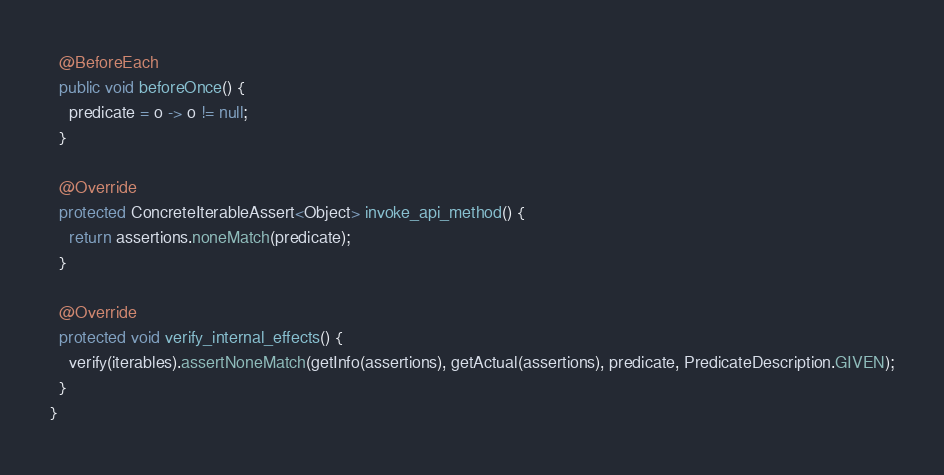Convert code to text. <code><loc_0><loc_0><loc_500><loc_500><_Java_>
  @BeforeEach
  public void beforeOnce() {
    predicate = o -> o != null;
  }

  @Override
  protected ConcreteIterableAssert<Object> invoke_api_method() {
    return assertions.noneMatch(predicate);
  }

  @Override
  protected void verify_internal_effects() {
    verify(iterables).assertNoneMatch(getInfo(assertions), getActual(assertions), predicate, PredicateDescription.GIVEN);
  }
}
</code> 